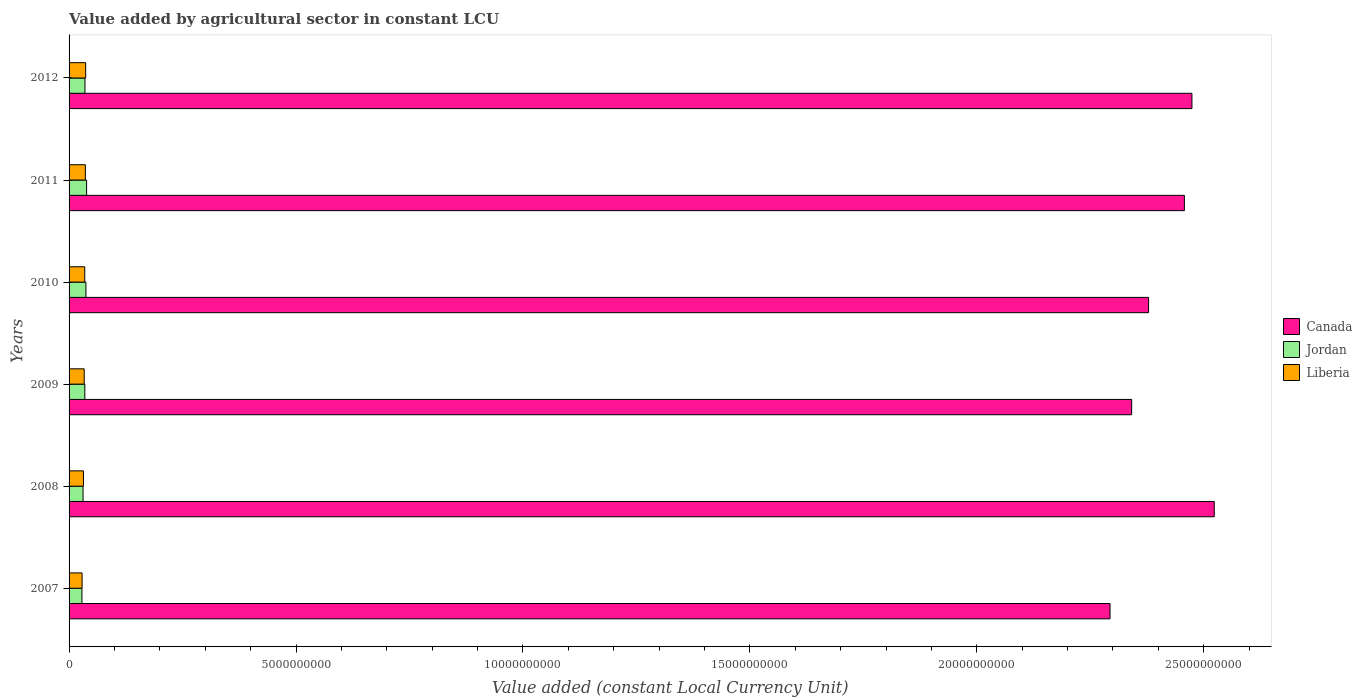How many different coloured bars are there?
Give a very brief answer. 3. How many groups of bars are there?
Keep it short and to the point. 6. How many bars are there on the 2nd tick from the top?
Make the answer very short. 3. What is the value added by agricultural sector in Canada in 2012?
Your answer should be compact. 2.47e+1. Across all years, what is the maximum value added by agricultural sector in Liberia?
Ensure brevity in your answer.  3.66e+08. Across all years, what is the minimum value added by agricultural sector in Liberia?
Provide a succinct answer. 2.87e+08. What is the total value added by agricultural sector in Liberia in the graph?
Your answer should be compact. 2.01e+09. What is the difference between the value added by agricultural sector in Jordan in 2007 and that in 2008?
Make the answer very short. -2.44e+07. What is the difference between the value added by agricultural sector in Canada in 2010 and the value added by agricultural sector in Jordan in 2008?
Ensure brevity in your answer.  2.35e+1. What is the average value added by agricultural sector in Canada per year?
Offer a terse response. 2.41e+1. In the year 2011, what is the difference between the value added by agricultural sector in Canada and value added by agricultural sector in Liberia?
Make the answer very short. 2.42e+1. In how many years, is the value added by agricultural sector in Liberia greater than 12000000000 LCU?
Provide a succinct answer. 0. What is the ratio of the value added by agricultural sector in Liberia in 2011 to that in 2012?
Offer a very short reply. 0.98. Is the value added by agricultural sector in Canada in 2008 less than that in 2010?
Offer a terse response. No. What is the difference between the highest and the second highest value added by agricultural sector in Liberia?
Offer a terse response. 6.83e+06. What is the difference between the highest and the lowest value added by agricultural sector in Liberia?
Give a very brief answer. 7.92e+07. In how many years, is the value added by agricultural sector in Liberia greater than the average value added by agricultural sector in Liberia taken over all years?
Keep it short and to the point. 3. Is the sum of the value added by agricultural sector in Liberia in 2009 and 2012 greater than the maximum value added by agricultural sector in Jordan across all years?
Provide a short and direct response. Yes. What does the 2nd bar from the bottom in 2008 represents?
Your response must be concise. Jordan. How many bars are there?
Keep it short and to the point. 18. How many years are there in the graph?
Provide a succinct answer. 6. What is the difference between two consecutive major ticks on the X-axis?
Your answer should be very brief. 5.00e+09. Are the values on the major ticks of X-axis written in scientific E-notation?
Your answer should be compact. No. How many legend labels are there?
Your response must be concise. 3. What is the title of the graph?
Your answer should be compact. Value added by agricultural sector in constant LCU. Does "Tuvalu" appear as one of the legend labels in the graph?
Ensure brevity in your answer.  No. What is the label or title of the X-axis?
Your answer should be very brief. Value added (constant Local Currency Unit). What is the Value added (constant Local Currency Unit) of Canada in 2007?
Your answer should be very brief. 2.29e+1. What is the Value added (constant Local Currency Unit) of Jordan in 2007?
Give a very brief answer. 2.83e+08. What is the Value added (constant Local Currency Unit) of Liberia in 2007?
Provide a succinct answer. 2.87e+08. What is the Value added (constant Local Currency Unit) of Canada in 2008?
Your answer should be compact. 2.52e+1. What is the Value added (constant Local Currency Unit) of Jordan in 2008?
Ensure brevity in your answer.  3.08e+08. What is the Value added (constant Local Currency Unit) of Liberia in 2008?
Offer a very short reply. 3.17e+08. What is the Value added (constant Local Currency Unit) of Canada in 2009?
Your answer should be very brief. 2.34e+1. What is the Value added (constant Local Currency Unit) of Jordan in 2009?
Provide a short and direct response. 3.47e+08. What is the Value added (constant Local Currency Unit) in Liberia in 2009?
Your answer should be compact. 3.33e+08. What is the Value added (constant Local Currency Unit) of Canada in 2010?
Your response must be concise. 2.38e+1. What is the Value added (constant Local Currency Unit) in Jordan in 2010?
Ensure brevity in your answer.  3.71e+08. What is the Value added (constant Local Currency Unit) of Liberia in 2010?
Provide a short and direct response. 3.45e+08. What is the Value added (constant Local Currency Unit) of Canada in 2011?
Provide a short and direct response. 2.46e+1. What is the Value added (constant Local Currency Unit) of Jordan in 2011?
Give a very brief answer. 3.86e+08. What is the Value added (constant Local Currency Unit) of Liberia in 2011?
Your response must be concise. 3.59e+08. What is the Value added (constant Local Currency Unit) of Canada in 2012?
Your answer should be compact. 2.47e+1. What is the Value added (constant Local Currency Unit) of Jordan in 2012?
Give a very brief answer. 3.50e+08. What is the Value added (constant Local Currency Unit) in Liberia in 2012?
Keep it short and to the point. 3.66e+08. Across all years, what is the maximum Value added (constant Local Currency Unit) of Canada?
Your response must be concise. 2.52e+1. Across all years, what is the maximum Value added (constant Local Currency Unit) in Jordan?
Ensure brevity in your answer.  3.86e+08. Across all years, what is the maximum Value added (constant Local Currency Unit) in Liberia?
Ensure brevity in your answer.  3.66e+08. Across all years, what is the minimum Value added (constant Local Currency Unit) of Canada?
Make the answer very short. 2.29e+1. Across all years, what is the minimum Value added (constant Local Currency Unit) in Jordan?
Your answer should be compact. 2.83e+08. Across all years, what is the minimum Value added (constant Local Currency Unit) of Liberia?
Make the answer very short. 2.87e+08. What is the total Value added (constant Local Currency Unit) of Canada in the graph?
Offer a terse response. 1.45e+11. What is the total Value added (constant Local Currency Unit) of Jordan in the graph?
Provide a short and direct response. 2.05e+09. What is the total Value added (constant Local Currency Unit) of Liberia in the graph?
Keep it short and to the point. 2.01e+09. What is the difference between the Value added (constant Local Currency Unit) of Canada in 2007 and that in 2008?
Ensure brevity in your answer.  -2.30e+09. What is the difference between the Value added (constant Local Currency Unit) of Jordan in 2007 and that in 2008?
Your answer should be compact. -2.44e+07. What is the difference between the Value added (constant Local Currency Unit) in Liberia in 2007 and that in 2008?
Offer a terse response. -3.02e+07. What is the difference between the Value added (constant Local Currency Unit) of Canada in 2007 and that in 2009?
Make the answer very short. -4.77e+08. What is the difference between the Value added (constant Local Currency Unit) in Jordan in 2007 and that in 2009?
Keep it short and to the point. -6.39e+07. What is the difference between the Value added (constant Local Currency Unit) in Liberia in 2007 and that in 2009?
Make the answer very short. -4.69e+07. What is the difference between the Value added (constant Local Currency Unit) of Canada in 2007 and that in 2010?
Ensure brevity in your answer.  -8.49e+08. What is the difference between the Value added (constant Local Currency Unit) of Jordan in 2007 and that in 2010?
Provide a short and direct response. -8.79e+07. What is the difference between the Value added (constant Local Currency Unit) in Liberia in 2007 and that in 2010?
Provide a short and direct response. -5.89e+07. What is the difference between the Value added (constant Local Currency Unit) of Canada in 2007 and that in 2011?
Your answer should be very brief. -1.64e+09. What is the difference between the Value added (constant Local Currency Unit) in Jordan in 2007 and that in 2011?
Provide a short and direct response. -1.03e+08. What is the difference between the Value added (constant Local Currency Unit) of Liberia in 2007 and that in 2011?
Offer a terse response. -7.24e+07. What is the difference between the Value added (constant Local Currency Unit) in Canada in 2007 and that in 2012?
Ensure brevity in your answer.  -1.80e+09. What is the difference between the Value added (constant Local Currency Unit) of Jordan in 2007 and that in 2012?
Provide a succinct answer. -6.65e+07. What is the difference between the Value added (constant Local Currency Unit) in Liberia in 2007 and that in 2012?
Offer a very short reply. -7.92e+07. What is the difference between the Value added (constant Local Currency Unit) in Canada in 2008 and that in 2009?
Offer a terse response. 1.82e+09. What is the difference between the Value added (constant Local Currency Unit) of Jordan in 2008 and that in 2009?
Ensure brevity in your answer.  -3.95e+07. What is the difference between the Value added (constant Local Currency Unit) in Liberia in 2008 and that in 2009?
Provide a short and direct response. -1.67e+07. What is the difference between the Value added (constant Local Currency Unit) of Canada in 2008 and that in 2010?
Offer a very short reply. 1.45e+09. What is the difference between the Value added (constant Local Currency Unit) in Jordan in 2008 and that in 2010?
Provide a succinct answer. -6.35e+07. What is the difference between the Value added (constant Local Currency Unit) in Liberia in 2008 and that in 2010?
Offer a very short reply. -2.87e+07. What is the difference between the Value added (constant Local Currency Unit) of Canada in 2008 and that in 2011?
Provide a succinct answer. 6.58e+08. What is the difference between the Value added (constant Local Currency Unit) in Jordan in 2008 and that in 2011?
Your answer should be very brief. -7.81e+07. What is the difference between the Value added (constant Local Currency Unit) of Liberia in 2008 and that in 2011?
Offer a very short reply. -4.21e+07. What is the difference between the Value added (constant Local Currency Unit) of Canada in 2008 and that in 2012?
Provide a succinct answer. 4.92e+08. What is the difference between the Value added (constant Local Currency Unit) of Jordan in 2008 and that in 2012?
Your answer should be very brief. -4.20e+07. What is the difference between the Value added (constant Local Currency Unit) in Liberia in 2008 and that in 2012?
Your answer should be compact. -4.90e+07. What is the difference between the Value added (constant Local Currency Unit) in Canada in 2009 and that in 2010?
Provide a succinct answer. -3.73e+08. What is the difference between the Value added (constant Local Currency Unit) of Jordan in 2009 and that in 2010?
Provide a short and direct response. -2.40e+07. What is the difference between the Value added (constant Local Currency Unit) of Liberia in 2009 and that in 2010?
Your response must be concise. -1.20e+07. What is the difference between the Value added (constant Local Currency Unit) of Canada in 2009 and that in 2011?
Offer a terse response. -1.16e+09. What is the difference between the Value added (constant Local Currency Unit) of Jordan in 2009 and that in 2011?
Offer a very short reply. -3.86e+07. What is the difference between the Value added (constant Local Currency Unit) of Liberia in 2009 and that in 2011?
Offer a terse response. -2.54e+07. What is the difference between the Value added (constant Local Currency Unit) in Canada in 2009 and that in 2012?
Offer a terse response. -1.33e+09. What is the difference between the Value added (constant Local Currency Unit) in Jordan in 2009 and that in 2012?
Provide a short and direct response. -2.55e+06. What is the difference between the Value added (constant Local Currency Unit) in Liberia in 2009 and that in 2012?
Your answer should be very brief. -3.23e+07. What is the difference between the Value added (constant Local Currency Unit) of Canada in 2010 and that in 2011?
Give a very brief answer. -7.89e+08. What is the difference between the Value added (constant Local Currency Unit) of Jordan in 2010 and that in 2011?
Offer a very short reply. -1.46e+07. What is the difference between the Value added (constant Local Currency Unit) in Liberia in 2010 and that in 2011?
Provide a short and direct response. -1.34e+07. What is the difference between the Value added (constant Local Currency Unit) in Canada in 2010 and that in 2012?
Your answer should be very brief. -9.55e+08. What is the difference between the Value added (constant Local Currency Unit) of Jordan in 2010 and that in 2012?
Ensure brevity in your answer.  2.15e+07. What is the difference between the Value added (constant Local Currency Unit) of Liberia in 2010 and that in 2012?
Offer a very short reply. -2.03e+07. What is the difference between the Value added (constant Local Currency Unit) in Canada in 2011 and that in 2012?
Provide a short and direct response. -1.67e+08. What is the difference between the Value added (constant Local Currency Unit) in Jordan in 2011 and that in 2012?
Make the answer very short. 3.61e+07. What is the difference between the Value added (constant Local Currency Unit) of Liberia in 2011 and that in 2012?
Offer a terse response. -6.83e+06. What is the difference between the Value added (constant Local Currency Unit) of Canada in 2007 and the Value added (constant Local Currency Unit) of Jordan in 2008?
Provide a succinct answer. 2.26e+1. What is the difference between the Value added (constant Local Currency Unit) in Canada in 2007 and the Value added (constant Local Currency Unit) in Liberia in 2008?
Make the answer very short. 2.26e+1. What is the difference between the Value added (constant Local Currency Unit) of Jordan in 2007 and the Value added (constant Local Currency Unit) of Liberia in 2008?
Give a very brief answer. -3.34e+07. What is the difference between the Value added (constant Local Currency Unit) of Canada in 2007 and the Value added (constant Local Currency Unit) of Jordan in 2009?
Your response must be concise. 2.26e+1. What is the difference between the Value added (constant Local Currency Unit) of Canada in 2007 and the Value added (constant Local Currency Unit) of Liberia in 2009?
Provide a short and direct response. 2.26e+1. What is the difference between the Value added (constant Local Currency Unit) in Jordan in 2007 and the Value added (constant Local Currency Unit) in Liberia in 2009?
Give a very brief answer. -5.01e+07. What is the difference between the Value added (constant Local Currency Unit) of Canada in 2007 and the Value added (constant Local Currency Unit) of Jordan in 2010?
Your answer should be compact. 2.26e+1. What is the difference between the Value added (constant Local Currency Unit) of Canada in 2007 and the Value added (constant Local Currency Unit) of Liberia in 2010?
Your answer should be very brief. 2.26e+1. What is the difference between the Value added (constant Local Currency Unit) in Jordan in 2007 and the Value added (constant Local Currency Unit) in Liberia in 2010?
Your response must be concise. -6.21e+07. What is the difference between the Value added (constant Local Currency Unit) in Canada in 2007 and the Value added (constant Local Currency Unit) in Jordan in 2011?
Give a very brief answer. 2.25e+1. What is the difference between the Value added (constant Local Currency Unit) in Canada in 2007 and the Value added (constant Local Currency Unit) in Liberia in 2011?
Your answer should be compact. 2.26e+1. What is the difference between the Value added (constant Local Currency Unit) of Jordan in 2007 and the Value added (constant Local Currency Unit) of Liberia in 2011?
Provide a succinct answer. -7.56e+07. What is the difference between the Value added (constant Local Currency Unit) in Canada in 2007 and the Value added (constant Local Currency Unit) in Jordan in 2012?
Your answer should be compact. 2.26e+1. What is the difference between the Value added (constant Local Currency Unit) in Canada in 2007 and the Value added (constant Local Currency Unit) in Liberia in 2012?
Your response must be concise. 2.26e+1. What is the difference between the Value added (constant Local Currency Unit) of Jordan in 2007 and the Value added (constant Local Currency Unit) of Liberia in 2012?
Provide a short and direct response. -8.24e+07. What is the difference between the Value added (constant Local Currency Unit) of Canada in 2008 and the Value added (constant Local Currency Unit) of Jordan in 2009?
Give a very brief answer. 2.49e+1. What is the difference between the Value added (constant Local Currency Unit) in Canada in 2008 and the Value added (constant Local Currency Unit) in Liberia in 2009?
Offer a terse response. 2.49e+1. What is the difference between the Value added (constant Local Currency Unit) in Jordan in 2008 and the Value added (constant Local Currency Unit) in Liberia in 2009?
Offer a terse response. -2.57e+07. What is the difference between the Value added (constant Local Currency Unit) of Canada in 2008 and the Value added (constant Local Currency Unit) of Jordan in 2010?
Give a very brief answer. 2.49e+1. What is the difference between the Value added (constant Local Currency Unit) in Canada in 2008 and the Value added (constant Local Currency Unit) in Liberia in 2010?
Make the answer very short. 2.49e+1. What is the difference between the Value added (constant Local Currency Unit) in Jordan in 2008 and the Value added (constant Local Currency Unit) in Liberia in 2010?
Offer a terse response. -3.77e+07. What is the difference between the Value added (constant Local Currency Unit) of Canada in 2008 and the Value added (constant Local Currency Unit) of Jordan in 2011?
Ensure brevity in your answer.  2.48e+1. What is the difference between the Value added (constant Local Currency Unit) of Canada in 2008 and the Value added (constant Local Currency Unit) of Liberia in 2011?
Your answer should be compact. 2.49e+1. What is the difference between the Value added (constant Local Currency Unit) of Jordan in 2008 and the Value added (constant Local Currency Unit) of Liberia in 2011?
Make the answer very short. -5.11e+07. What is the difference between the Value added (constant Local Currency Unit) in Canada in 2008 and the Value added (constant Local Currency Unit) in Jordan in 2012?
Your response must be concise. 2.49e+1. What is the difference between the Value added (constant Local Currency Unit) of Canada in 2008 and the Value added (constant Local Currency Unit) of Liberia in 2012?
Your answer should be compact. 2.49e+1. What is the difference between the Value added (constant Local Currency Unit) in Jordan in 2008 and the Value added (constant Local Currency Unit) in Liberia in 2012?
Provide a short and direct response. -5.80e+07. What is the difference between the Value added (constant Local Currency Unit) in Canada in 2009 and the Value added (constant Local Currency Unit) in Jordan in 2010?
Keep it short and to the point. 2.30e+1. What is the difference between the Value added (constant Local Currency Unit) of Canada in 2009 and the Value added (constant Local Currency Unit) of Liberia in 2010?
Offer a very short reply. 2.31e+1. What is the difference between the Value added (constant Local Currency Unit) in Jordan in 2009 and the Value added (constant Local Currency Unit) in Liberia in 2010?
Give a very brief answer. 1.79e+06. What is the difference between the Value added (constant Local Currency Unit) of Canada in 2009 and the Value added (constant Local Currency Unit) of Jordan in 2011?
Your response must be concise. 2.30e+1. What is the difference between the Value added (constant Local Currency Unit) in Canada in 2009 and the Value added (constant Local Currency Unit) in Liberia in 2011?
Offer a very short reply. 2.31e+1. What is the difference between the Value added (constant Local Currency Unit) in Jordan in 2009 and the Value added (constant Local Currency Unit) in Liberia in 2011?
Your response must be concise. -1.16e+07. What is the difference between the Value added (constant Local Currency Unit) in Canada in 2009 and the Value added (constant Local Currency Unit) in Jordan in 2012?
Provide a succinct answer. 2.31e+1. What is the difference between the Value added (constant Local Currency Unit) of Canada in 2009 and the Value added (constant Local Currency Unit) of Liberia in 2012?
Your answer should be very brief. 2.30e+1. What is the difference between the Value added (constant Local Currency Unit) of Jordan in 2009 and the Value added (constant Local Currency Unit) of Liberia in 2012?
Your answer should be compact. -1.85e+07. What is the difference between the Value added (constant Local Currency Unit) of Canada in 2010 and the Value added (constant Local Currency Unit) of Jordan in 2011?
Your response must be concise. 2.34e+1. What is the difference between the Value added (constant Local Currency Unit) in Canada in 2010 and the Value added (constant Local Currency Unit) in Liberia in 2011?
Ensure brevity in your answer.  2.34e+1. What is the difference between the Value added (constant Local Currency Unit) of Jordan in 2010 and the Value added (constant Local Currency Unit) of Liberia in 2011?
Your response must be concise. 1.24e+07. What is the difference between the Value added (constant Local Currency Unit) of Canada in 2010 and the Value added (constant Local Currency Unit) of Jordan in 2012?
Your answer should be very brief. 2.34e+1. What is the difference between the Value added (constant Local Currency Unit) in Canada in 2010 and the Value added (constant Local Currency Unit) in Liberia in 2012?
Your answer should be very brief. 2.34e+1. What is the difference between the Value added (constant Local Currency Unit) in Jordan in 2010 and the Value added (constant Local Currency Unit) in Liberia in 2012?
Your answer should be compact. 5.53e+06. What is the difference between the Value added (constant Local Currency Unit) in Canada in 2011 and the Value added (constant Local Currency Unit) in Jordan in 2012?
Ensure brevity in your answer.  2.42e+1. What is the difference between the Value added (constant Local Currency Unit) in Canada in 2011 and the Value added (constant Local Currency Unit) in Liberia in 2012?
Provide a short and direct response. 2.42e+1. What is the difference between the Value added (constant Local Currency Unit) of Jordan in 2011 and the Value added (constant Local Currency Unit) of Liberia in 2012?
Make the answer very short. 2.02e+07. What is the average Value added (constant Local Currency Unit) in Canada per year?
Keep it short and to the point. 2.41e+1. What is the average Value added (constant Local Currency Unit) in Jordan per year?
Keep it short and to the point. 3.41e+08. What is the average Value added (constant Local Currency Unit) in Liberia per year?
Offer a terse response. 3.35e+08. In the year 2007, what is the difference between the Value added (constant Local Currency Unit) of Canada and Value added (constant Local Currency Unit) of Jordan?
Make the answer very short. 2.27e+1. In the year 2007, what is the difference between the Value added (constant Local Currency Unit) of Canada and Value added (constant Local Currency Unit) of Liberia?
Offer a terse response. 2.26e+1. In the year 2007, what is the difference between the Value added (constant Local Currency Unit) of Jordan and Value added (constant Local Currency Unit) of Liberia?
Offer a very short reply. -3.20e+06. In the year 2008, what is the difference between the Value added (constant Local Currency Unit) of Canada and Value added (constant Local Currency Unit) of Jordan?
Your answer should be very brief. 2.49e+1. In the year 2008, what is the difference between the Value added (constant Local Currency Unit) of Canada and Value added (constant Local Currency Unit) of Liberia?
Provide a short and direct response. 2.49e+1. In the year 2008, what is the difference between the Value added (constant Local Currency Unit) in Jordan and Value added (constant Local Currency Unit) in Liberia?
Your answer should be compact. -9.00e+06. In the year 2009, what is the difference between the Value added (constant Local Currency Unit) of Canada and Value added (constant Local Currency Unit) of Jordan?
Your response must be concise. 2.31e+1. In the year 2009, what is the difference between the Value added (constant Local Currency Unit) in Canada and Value added (constant Local Currency Unit) in Liberia?
Your response must be concise. 2.31e+1. In the year 2009, what is the difference between the Value added (constant Local Currency Unit) in Jordan and Value added (constant Local Currency Unit) in Liberia?
Keep it short and to the point. 1.38e+07. In the year 2010, what is the difference between the Value added (constant Local Currency Unit) of Canada and Value added (constant Local Currency Unit) of Jordan?
Offer a very short reply. 2.34e+1. In the year 2010, what is the difference between the Value added (constant Local Currency Unit) of Canada and Value added (constant Local Currency Unit) of Liberia?
Keep it short and to the point. 2.34e+1. In the year 2010, what is the difference between the Value added (constant Local Currency Unit) of Jordan and Value added (constant Local Currency Unit) of Liberia?
Make the answer very short. 2.58e+07. In the year 2011, what is the difference between the Value added (constant Local Currency Unit) of Canada and Value added (constant Local Currency Unit) of Jordan?
Offer a very short reply. 2.42e+1. In the year 2011, what is the difference between the Value added (constant Local Currency Unit) of Canada and Value added (constant Local Currency Unit) of Liberia?
Provide a short and direct response. 2.42e+1. In the year 2011, what is the difference between the Value added (constant Local Currency Unit) in Jordan and Value added (constant Local Currency Unit) in Liberia?
Offer a terse response. 2.70e+07. In the year 2012, what is the difference between the Value added (constant Local Currency Unit) of Canada and Value added (constant Local Currency Unit) of Jordan?
Give a very brief answer. 2.44e+1. In the year 2012, what is the difference between the Value added (constant Local Currency Unit) of Canada and Value added (constant Local Currency Unit) of Liberia?
Your response must be concise. 2.44e+1. In the year 2012, what is the difference between the Value added (constant Local Currency Unit) of Jordan and Value added (constant Local Currency Unit) of Liberia?
Offer a terse response. -1.59e+07. What is the ratio of the Value added (constant Local Currency Unit) in Canada in 2007 to that in 2008?
Ensure brevity in your answer.  0.91. What is the ratio of the Value added (constant Local Currency Unit) in Jordan in 2007 to that in 2008?
Offer a very short reply. 0.92. What is the ratio of the Value added (constant Local Currency Unit) in Liberia in 2007 to that in 2008?
Offer a terse response. 0.9. What is the ratio of the Value added (constant Local Currency Unit) in Canada in 2007 to that in 2009?
Make the answer very short. 0.98. What is the ratio of the Value added (constant Local Currency Unit) in Jordan in 2007 to that in 2009?
Your answer should be compact. 0.82. What is the ratio of the Value added (constant Local Currency Unit) of Liberia in 2007 to that in 2009?
Keep it short and to the point. 0.86. What is the ratio of the Value added (constant Local Currency Unit) of Jordan in 2007 to that in 2010?
Offer a terse response. 0.76. What is the ratio of the Value added (constant Local Currency Unit) of Liberia in 2007 to that in 2010?
Your response must be concise. 0.83. What is the ratio of the Value added (constant Local Currency Unit) of Jordan in 2007 to that in 2011?
Your response must be concise. 0.73. What is the ratio of the Value added (constant Local Currency Unit) of Liberia in 2007 to that in 2011?
Provide a short and direct response. 0.8. What is the ratio of the Value added (constant Local Currency Unit) in Canada in 2007 to that in 2012?
Offer a terse response. 0.93. What is the ratio of the Value added (constant Local Currency Unit) of Jordan in 2007 to that in 2012?
Make the answer very short. 0.81. What is the ratio of the Value added (constant Local Currency Unit) of Liberia in 2007 to that in 2012?
Your response must be concise. 0.78. What is the ratio of the Value added (constant Local Currency Unit) of Canada in 2008 to that in 2009?
Offer a very short reply. 1.08. What is the ratio of the Value added (constant Local Currency Unit) of Jordan in 2008 to that in 2009?
Ensure brevity in your answer.  0.89. What is the ratio of the Value added (constant Local Currency Unit) of Canada in 2008 to that in 2010?
Ensure brevity in your answer.  1.06. What is the ratio of the Value added (constant Local Currency Unit) in Jordan in 2008 to that in 2010?
Ensure brevity in your answer.  0.83. What is the ratio of the Value added (constant Local Currency Unit) of Liberia in 2008 to that in 2010?
Your response must be concise. 0.92. What is the ratio of the Value added (constant Local Currency Unit) of Canada in 2008 to that in 2011?
Your answer should be compact. 1.03. What is the ratio of the Value added (constant Local Currency Unit) of Jordan in 2008 to that in 2011?
Offer a very short reply. 0.8. What is the ratio of the Value added (constant Local Currency Unit) of Liberia in 2008 to that in 2011?
Make the answer very short. 0.88. What is the ratio of the Value added (constant Local Currency Unit) in Canada in 2008 to that in 2012?
Make the answer very short. 1.02. What is the ratio of the Value added (constant Local Currency Unit) of Jordan in 2008 to that in 2012?
Your answer should be compact. 0.88. What is the ratio of the Value added (constant Local Currency Unit) in Liberia in 2008 to that in 2012?
Make the answer very short. 0.87. What is the ratio of the Value added (constant Local Currency Unit) in Canada in 2009 to that in 2010?
Offer a very short reply. 0.98. What is the ratio of the Value added (constant Local Currency Unit) of Jordan in 2009 to that in 2010?
Offer a terse response. 0.94. What is the ratio of the Value added (constant Local Currency Unit) in Liberia in 2009 to that in 2010?
Make the answer very short. 0.97. What is the ratio of the Value added (constant Local Currency Unit) of Canada in 2009 to that in 2011?
Offer a terse response. 0.95. What is the ratio of the Value added (constant Local Currency Unit) of Jordan in 2009 to that in 2011?
Offer a very short reply. 0.9. What is the ratio of the Value added (constant Local Currency Unit) of Liberia in 2009 to that in 2011?
Provide a short and direct response. 0.93. What is the ratio of the Value added (constant Local Currency Unit) of Canada in 2009 to that in 2012?
Your answer should be very brief. 0.95. What is the ratio of the Value added (constant Local Currency Unit) of Liberia in 2009 to that in 2012?
Provide a succinct answer. 0.91. What is the ratio of the Value added (constant Local Currency Unit) in Canada in 2010 to that in 2011?
Provide a succinct answer. 0.97. What is the ratio of the Value added (constant Local Currency Unit) in Jordan in 2010 to that in 2011?
Offer a terse response. 0.96. What is the ratio of the Value added (constant Local Currency Unit) in Liberia in 2010 to that in 2011?
Your answer should be very brief. 0.96. What is the ratio of the Value added (constant Local Currency Unit) of Canada in 2010 to that in 2012?
Your response must be concise. 0.96. What is the ratio of the Value added (constant Local Currency Unit) of Jordan in 2010 to that in 2012?
Your answer should be very brief. 1.06. What is the ratio of the Value added (constant Local Currency Unit) in Liberia in 2010 to that in 2012?
Your response must be concise. 0.94. What is the ratio of the Value added (constant Local Currency Unit) of Canada in 2011 to that in 2012?
Your response must be concise. 0.99. What is the ratio of the Value added (constant Local Currency Unit) of Jordan in 2011 to that in 2012?
Your answer should be compact. 1.1. What is the ratio of the Value added (constant Local Currency Unit) in Liberia in 2011 to that in 2012?
Offer a very short reply. 0.98. What is the difference between the highest and the second highest Value added (constant Local Currency Unit) in Canada?
Offer a terse response. 4.92e+08. What is the difference between the highest and the second highest Value added (constant Local Currency Unit) in Jordan?
Make the answer very short. 1.46e+07. What is the difference between the highest and the second highest Value added (constant Local Currency Unit) of Liberia?
Offer a terse response. 6.83e+06. What is the difference between the highest and the lowest Value added (constant Local Currency Unit) of Canada?
Keep it short and to the point. 2.30e+09. What is the difference between the highest and the lowest Value added (constant Local Currency Unit) in Jordan?
Make the answer very short. 1.03e+08. What is the difference between the highest and the lowest Value added (constant Local Currency Unit) in Liberia?
Give a very brief answer. 7.92e+07. 